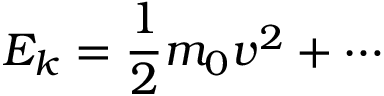<formula> <loc_0><loc_0><loc_500><loc_500>E _ { k } = { \frac { 1 } { 2 } } m _ { 0 } v ^ { 2 } + \cdots</formula> 